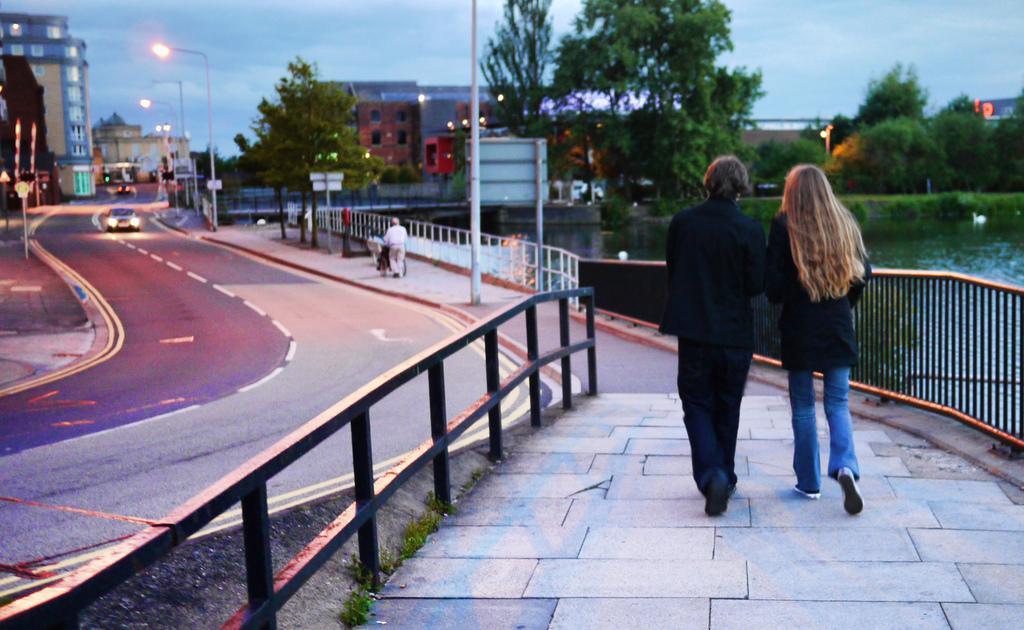How would you summarize this image in a sentence or two? In this picture we can see three persons walking, there is a car traveling on the road, on the right side we can see water, in the background there are some buildings, trees, poles, lights, some boards and shrubs, we can see the sky at the top of the picture. 